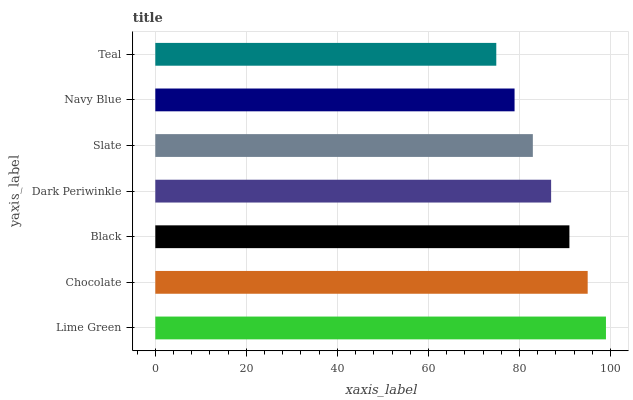Is Teal the minimum?
Answer yes or no. Yes. Is Lime Green the maximum?
Answer yes or no. Yes. Is Chocolate the minimum?
Answer yes or no. No. Is Chocolate the maximum?
Answer yes or no. No. Is Lime Green greater than Chocolate?
Answer yes or no. Yes. Is Chocolate less than Lime Green?
Answer yes or no. Yes. Is Chocolate greater than Lime Green?
Answer yes or no. No. Is Lime Green less than Chocolate?
Answer yes or no. No. Is Dark Periwinkle the high median?
Answer yes or no. Yes. Is Dark Periwinkle the low median?
Answer yes or no. Yes. Is Lime Green the high median?
Answer yes or no. No. Is Black the low median?
Answer yes or no. No. 